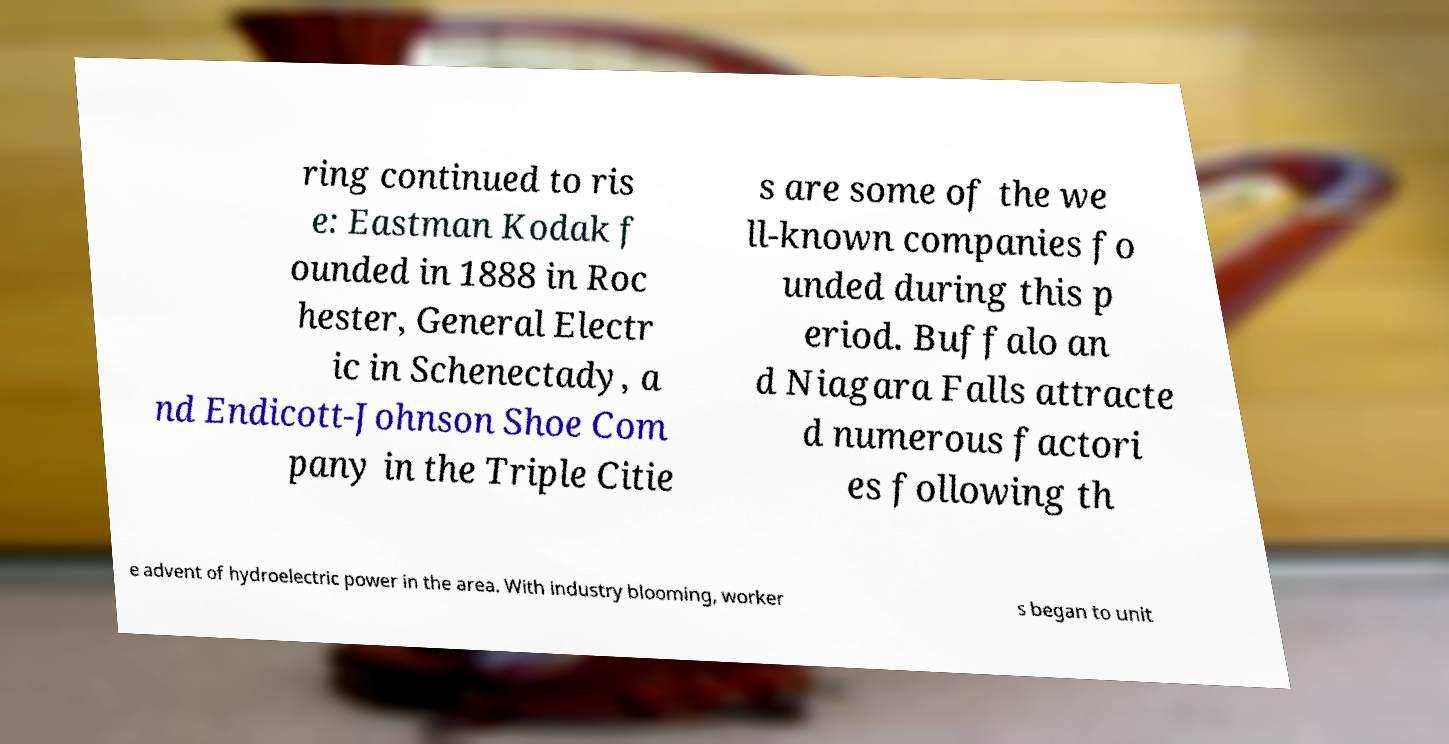What messages or text are displayed in this image? I need them in a readable, typed format. ring continued to ris e: Eastman Kodak f ounded in 1888 in Roc hester, General Electr ic in Schenectady, a nd Endicott-Johnson Shoe Com pany in the Triple Citie s are some of the we ll-known companies fo unded during this p eriod. Buffalo an d Niagara Falls attracte d numerous factori es following th e advent of hydroelectric power in the area. With industry blooming, worker s began to unit 